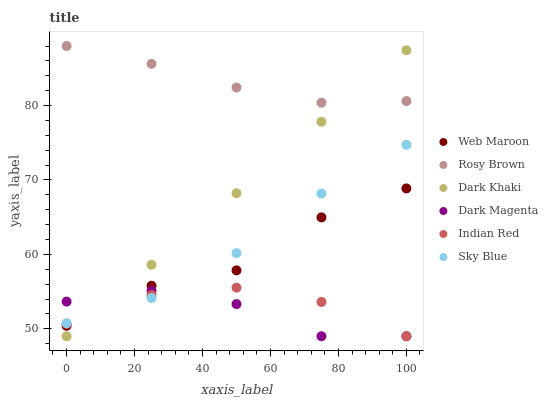Does Dark Magenta have the minimum area under the curve?
Answer yes or no. Yes. Does Rosy Brown have the maximum area under the curve?
Answer yes or no. Yes. Does Web Maroon have the minimum area under the curve?
Answer yes or no. No. Does Web Maroon have the maximum area under the curve?
Answer yes or no. No. Is Dark Khaki the smoothest?
Answer yes or no. Yes. Is Web Maroon the roughest?
Answer yes or no. Yes. Is Rosy Brown the smoothest?
Answer yes or no. No. Is Rosy Brown the roughest?
Answer yes or no. No. Does Dark Magenta have the lowest value?
Answer yes or no. Yes. Does Web Maroon have the lowest value?
Answer yes or no. No. Does Rosy Brown have the highest value?
Answer yes or no. Yes. Does Web Maroon have the highest value?
Answer yes or no. No. Is Indian Red less than Rosy Brown?
Answer yes or no. Yes. Is Rosy Brown greater than Dark Magenta?
Answer yes or no. Yes. Does Web Maroon intersect Dark Khaki?
Answer yes or no. Yes. Is Web Maroon less than Dark Khaki?
Answer yes or no. No. Is Web Maroon greater than Dark Khaki?
Answer yes or no. No. Does Indian Red intersect Rosy Brown?
Answer yes or no. No. 